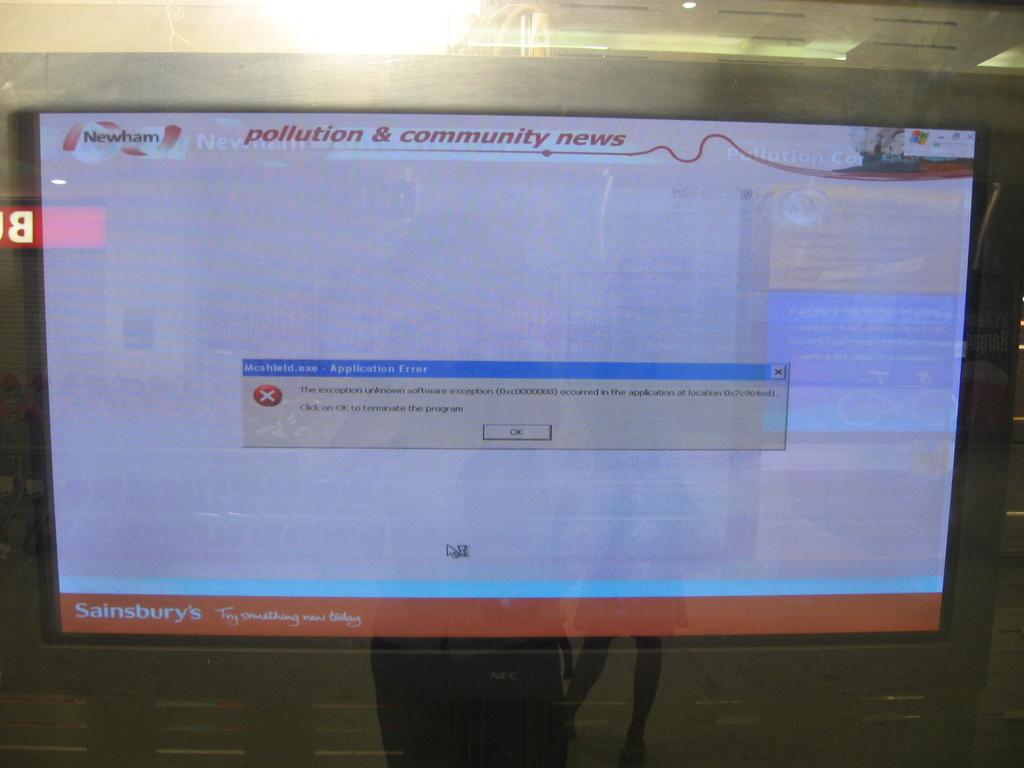What computer model is this?
Your response must be concise. Nec. What it is display?
Your answer should be compact. Pollution & community news. 